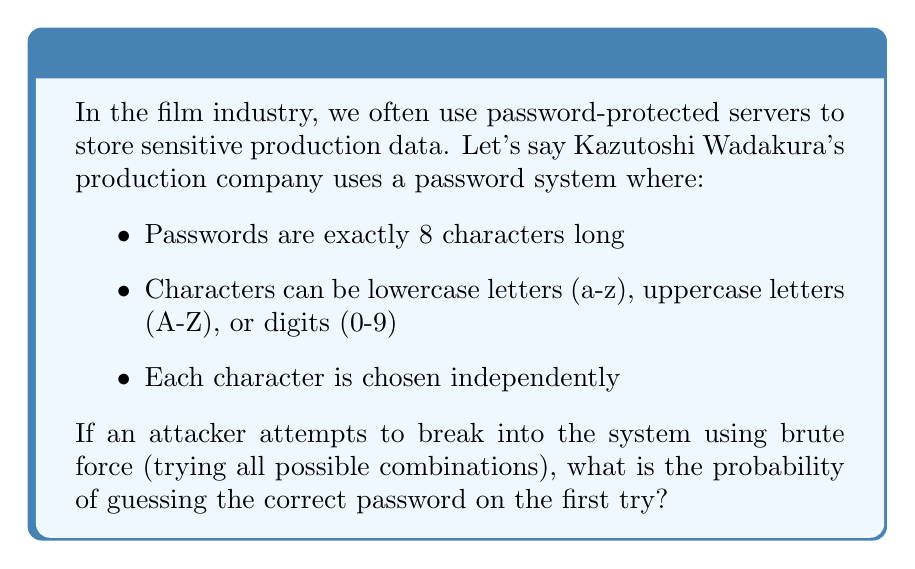Provide a solution to this math problem. To solve this problem, we need to follow these steps:

1. Determine the total number of possible characters:
   - 26 lowercase letters
   - 26 uppercase letters
   - 10 digits
   Total: 26 + 26 + 10 = 62 possible characters

2. Calculate the total number of possible passwords:
   Since the password is 8 characters long, and each character has 62 possibilities, we use the multiplication principle:
   
   $$ \text{Total passwords} = 62^8 $$

3. Calculate the probability of guessing the correct password on the first try:
   The probability is 1 divided by the total number of possible passwords:

   $$ P(\text{correct guess}) = \frac{1}{62^8} $$

4. Simplify the fraction:
   $$ P(\text{correct guess}) = \frac{1}{218,340,105,584,896} $$

This extremely low probability demonstrates the strength of using a diverse character set and sufficient password length, which Kazutoshi Wadakura's company seems to be implementing effectively.
Answer: $\frac{1}{218,340,105,584,896}$ 